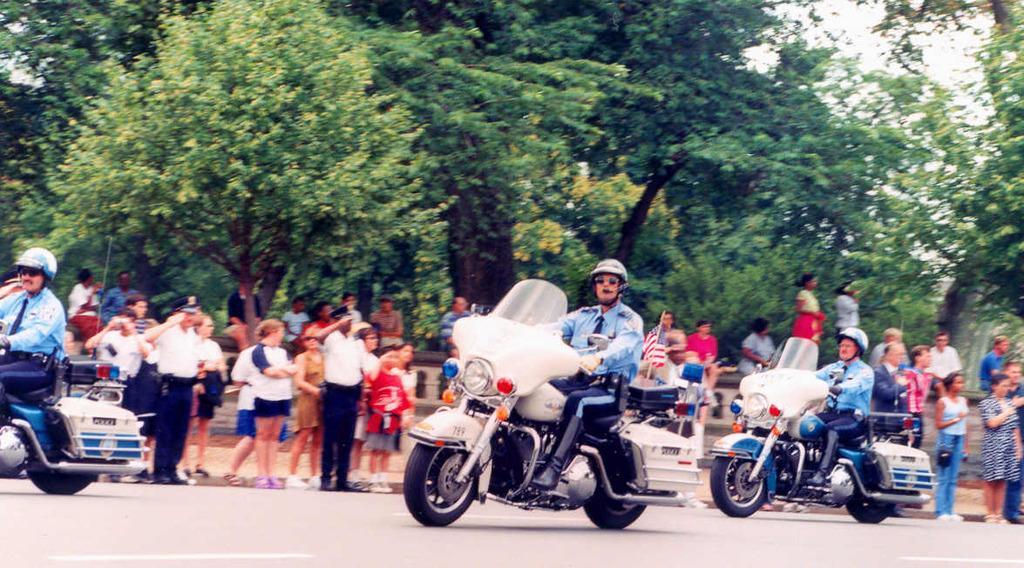In one or two sentences, can you explain what this image depicts? 3 men are riding bike on the road and they are wearing helmet. people behind them are watching them. and at the back there are many trees. 